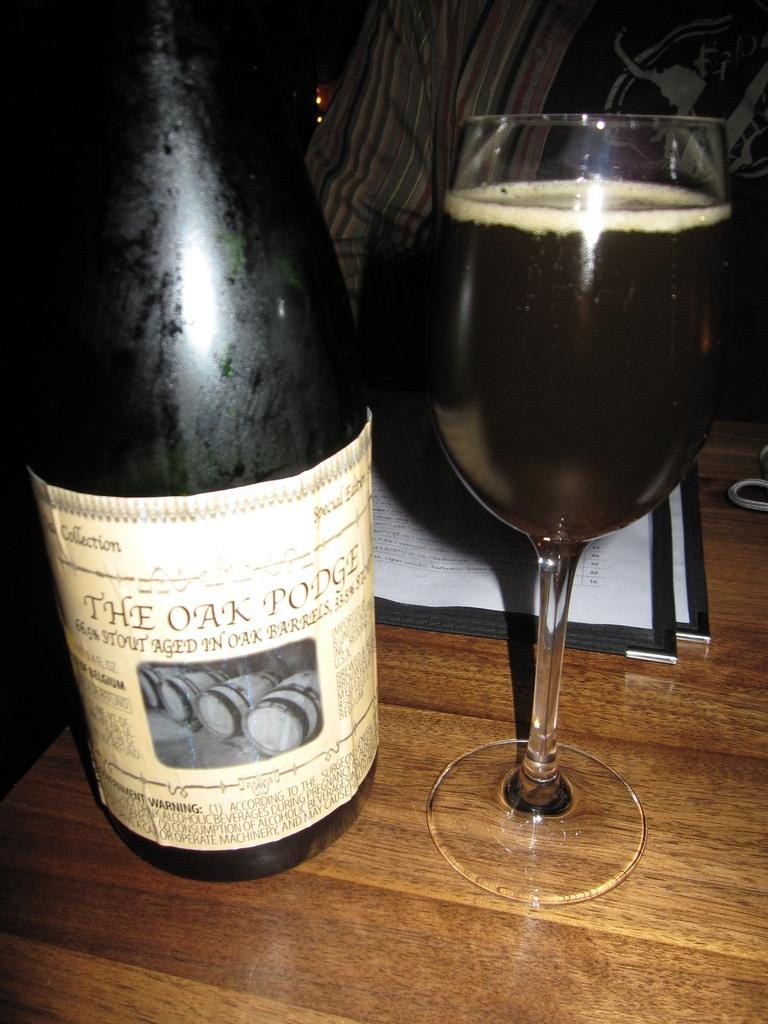What is present in the image that can hold a liquid? There is a bottle and a glass with a drink in the image. What else can be seen on the table in the image? There are papers on the table in the image. Is there anyone visible in the image? Yes, there is a person in the background of the image. What type of ornament is hanging from the ceiling in the image? There is no ornament hanging from the ceiling in the image. How does the snow affect the visibility of the objects in the image? There is no snow present in the image, so it does not affect the visibility of the objects. 